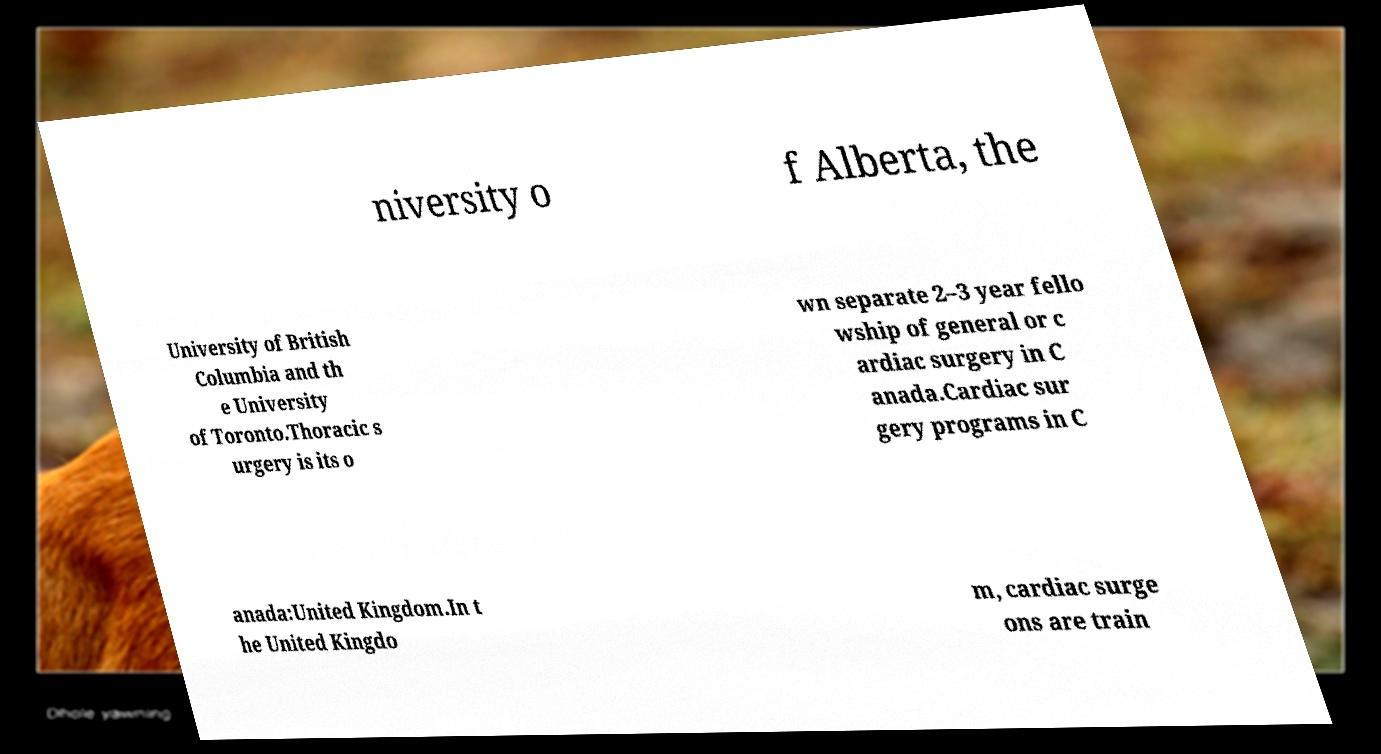Could you extract and type out the text from this image? niversity o f Alberta, the University of British Columbia and th e University of Toronto.Thoracic s urgery is its o wn separate 2–3 year fello wship of general or c ardiac surgery in C anada.Cardiac sur gery programs in C anada:United Kingdom.In t he United Kingdo m, cardiac surge ons are train 